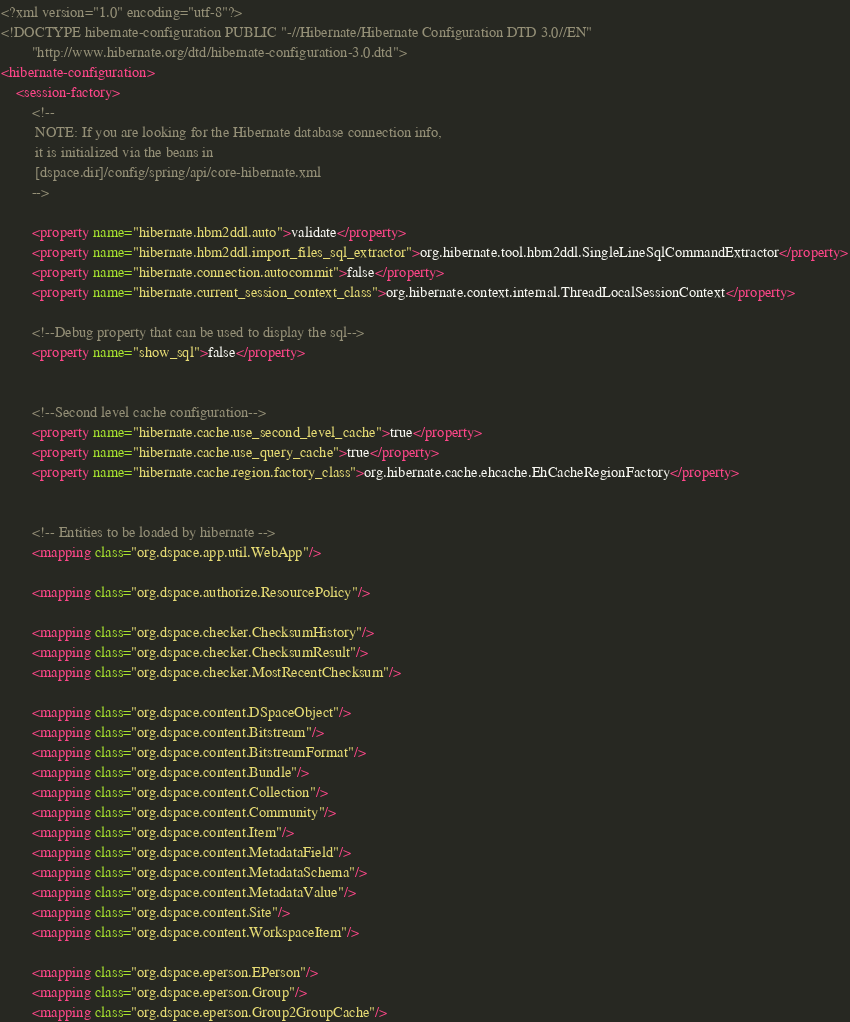<code> <loc_0><loc_0><loc_500><loc_500><_XML_><?xml version="1.0" encoding="utf-8"?>
<!DOCTYPE hibernate-configuration PUBLIC "-//Hibernate/Hibernate Configuration DTD 3.0//EN"
        "http://www.hibernate.org/dtd/hibernate-configuration-3.0.dtd">
<hibernate-configuration>
    <session-factory>
        <!--
         NOTE: If you are looking for the Hibernate database connection info,
         it is initialized via the beans in
         [dspace.dir]/config/spring/api/core-hibernate.xml
        -->

        <property name="hibernate.hbm2ddl.auto">validate</property>
        <property name="hibernate.hbm2ddl.import_files_sql_extractor">org.hibernate.tool.hbm2ddl.SingleLineSqlCommandExtractor</property>
        <property name="hibernate.connection.autocommit">false</property>
        <property name="hibernate.current_session_context_class">org.hibernate.context.internal.ThreadLocalSessionContext</property>

        <!--Debug property that can be used to display the sql-->
        <property name="show_sql">false</property>


        <!--Second level cache configuration-->
        <property name="hibernate.cache.use_second_level_cache">true</property>
        <property name="hibernate.cache.use_query_cache">true</property>
        <property name="hibernate.cache.region.factory_class">org.hibernate.cache.ehcache.EhCacheRegionFactory</property>


        <!-- Entities to be loaded by hibernate -->
        <mapping class="org.dspace.app.util.WebApp"/>

        <mapping class="org.dspace.authorize.ResourcePolicy"/>

        <mapping class="org.dspace.checker.ChecksumHistory"/>
        <mapping class="org.dspace.checker.ChecksumResult"/>
        <mapping class="org.dspace.checker.MostRecentChecksum"/>

        <mapping class="org.dspace.content.DSpaceObject"/>
        <mapping class="org.dspace.content.Bitstream"/>
        <mapping class="org.dspace.content.BitstreamFormat"/>
        <mapping class="org.dspace.content.Bundle"/>
        <mapping class="org.dspace.content.Collection"/>
        <mapping class="org.dspace.content.Community"/>
        <mapping class="org.dspace.content.Item"/>
        <mapping class="org.dspace.content.MetadataField"/>
        <mapping class="org.dspace.content.MetadataSchema"/>
        <mapping class="org.dspace.content.MetadataValue"/>
        <mapping class="org.dspace.content.Site"/>
        <mapping class="org.dspace.content.WorkspaceItem"/>

        <mapping class="org.dspace.eperson.EPerson"/>
        <mapping class="org.dspace.eperson.Group"/>
        <mapping class="org.dspace.eperson.Group2GroupCache"/></code> 